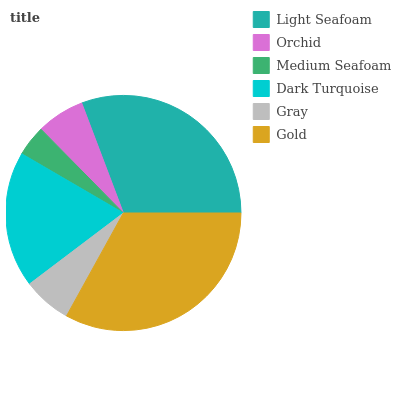Is Medium Seafoam the minimum?
Answer yes or no. Yes. Is Gold the maximum?
Answer yes or no. Yes. Is Orchid the minimum?
Answer yes or no. No. Is Orchid the maximum?
Answer yes or no. No. Is Light Seafoam greater than Orchid?
Answer yes or no. Yes. Is Orchid less than Light Seafoam?
Answer yes or no. Yes. Is Orchid greater than Light Seafoam?
Answer yes or no. No. Is Light Seafoam less than Orchid?
Answer yes or no. No. Is Dark Turquoise the high median?
Answer yes or no. Yes. Is Gray the low median?
Answer yes or no. Yes. Is Medium Seafoam the high median?
Answer yes or no. No. Is Orchid the low median?
Answer yes or no. No. 